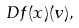<formula> <loc_0><loc_0><loc_500><loc_500>D f ( x ) ( v ) ,</formula> 